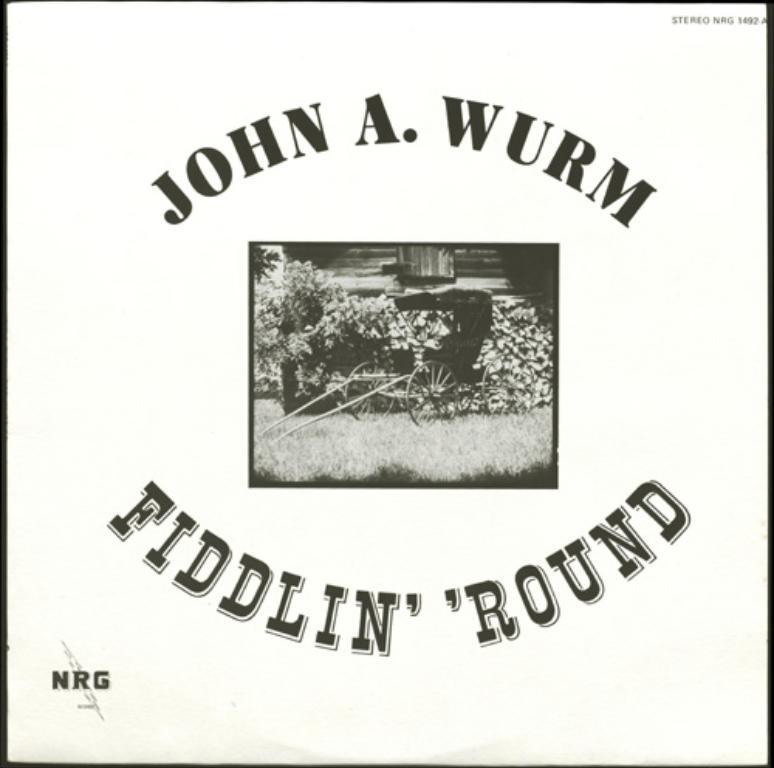What is featured on the poster in the image? The poster in the image has text on it and a logo at the bottom left corner. What type of object is present near the poster? There is a cart in the image. What type of vegetation can be seen in the image? There are plants and grass on the ground in the image. What type of structure is visible in the image? There is a building in the image. What type of song is being played by the goat in the image? There is no goat or song present in the image; it features a poster, cart, plants, grass, and a building. 